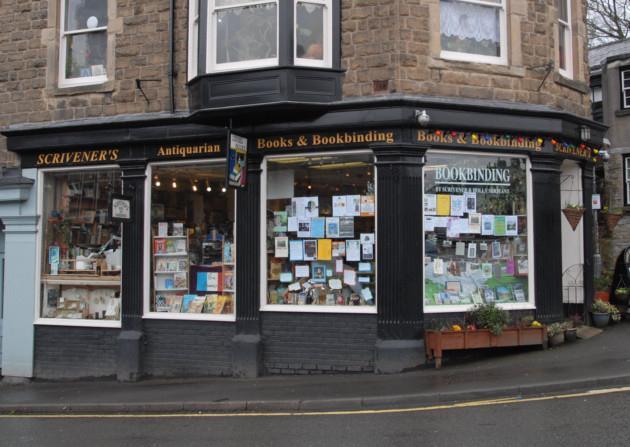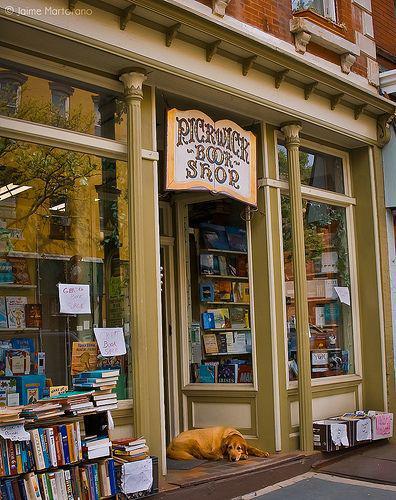The first image is the image on the left, the second image is the image on the right. For the images displayed, is the sentence "Both images feature the exterior of a bookshop." factually correct? Answer yes or no. Yes. The first image is the image on the left, the second image is the image on the right. For the images displayed, is the sentence "To the left of the build there is at least one folding sign advertising the shop." factually correct? Answer yes or no. No. 